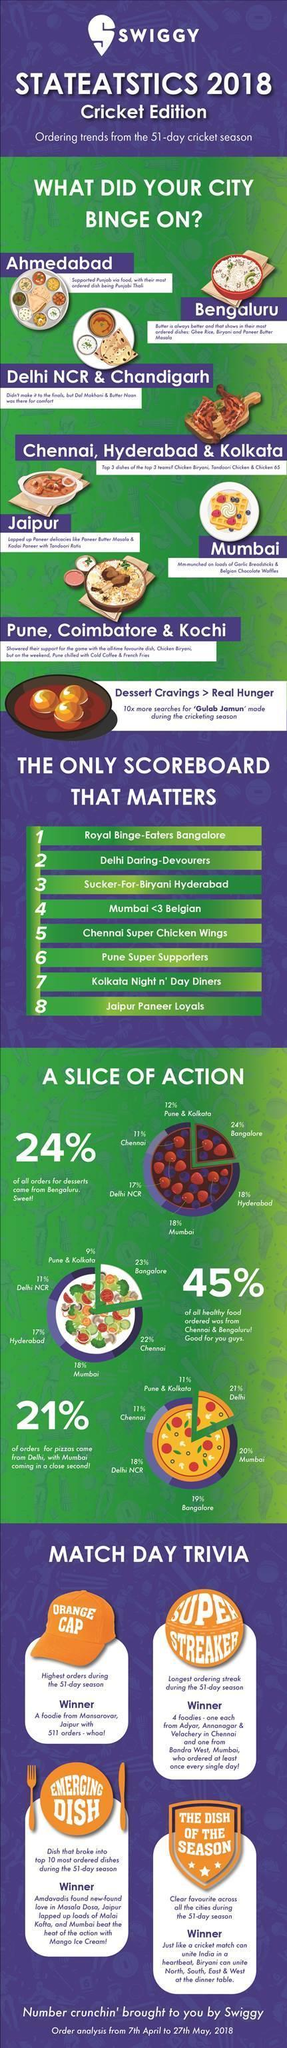what is the percentage of dessert orders from Mumbai and Delhi taken together?
Answer the question with a short phrase. 25 least number of dessert orders came from which city according to the pie chart? Chennai what is the percentage of dessert orders from Bangalore and Hyderabad taken together? 42 what is the percentage of healthy food orders from Mumbai and Hyderabad taken together? 25 what is the percentage of healthy food orders from Mumbai and Delhi taken together? 29% what is the percentage of pizza orders from Mumbai and Delhi taken together? 38 what is the percentage of dessert orders from Mumbai and Hyderabad taken together? 36% 